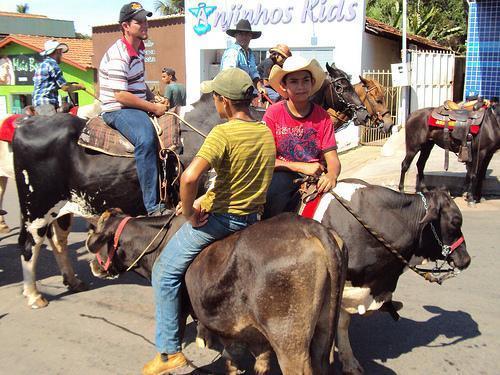How many cows are shown?
Give a very brief answer. 3. How many horses do not have riders?
Give a very brief answer. 1. 